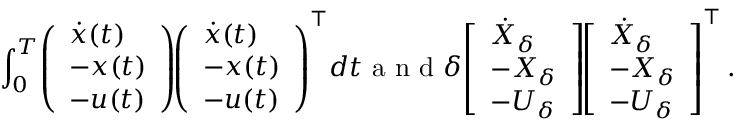<formula> <loc_0><loc_0><loc_500><loc_500>\int _ { 0 } ^ { T } \, \left ( \begin{array} { l } { \dot { x } ( t ) } \\ { - x ( t ) } \\ { - u ( t ) } \end{array} \right ) \, \left ( \begin{array} { l } { \dot { x } ( t ) } \\ { - x ( t ) } \\ { - u ( t ) } \end{array} \right ) ^ { \top } \, d t a n d \delta \, \left [ \begin{array} { l } { \dot { X } _ { \delta } } \\ { - X _ { \delta } } \\ { - U _ { \delta } } \end{array} \right ] \, \left [ \begin{array} { l } { \dot { X } _ { \delta } } \\ { - X _ { \delta } } \\ { - U _ { \delta } } \end{array} \right ] ^ { \top } .</formula> 